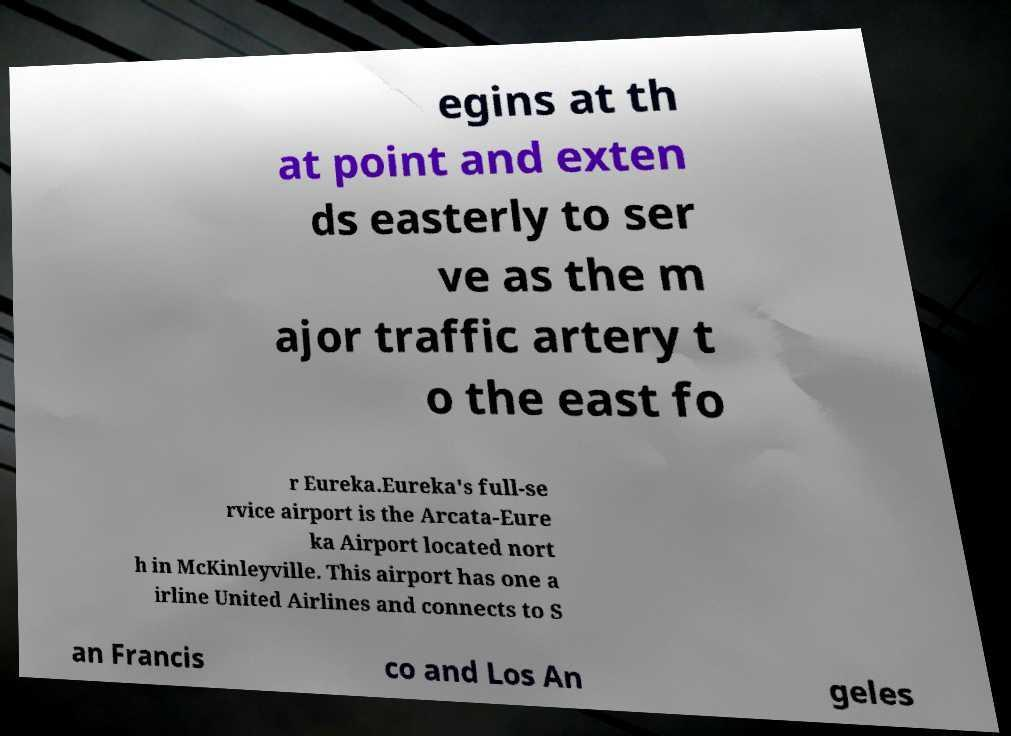Please read and relay the text visible in this image. What does it say? egins at th at point and exten ds easterly to ser ve as the m ajor traffic artery t o the east fo r Eureka.Eureka's full-se rvice airport is the Arcata-Eure ka Airport located nort h in McKinleyville. This airport has one a irline United Airlines and connects to S an Francis co and Los An geles 